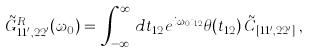Convert formula to latex. <formula><loc_0><loc_0><loc_500><loc_500>\tilde { G } ^ { R } _ { 1 1 ^ { \prime } , 2 2 ^ { \prime } } ( \omega _ { 0 } ) & = \, \int _ { - \infty } ^ { \infty } \, d t _ { 1 2 } e ^ { i \omega _ { 0 } t _ { 1 2 } } \theta ( t _ { 1 2 } ) \, \tilde { C } _ { [ 1 1 ^ { \prime } , 2 2 ^ { \prime } ] } \, ,</formula> 